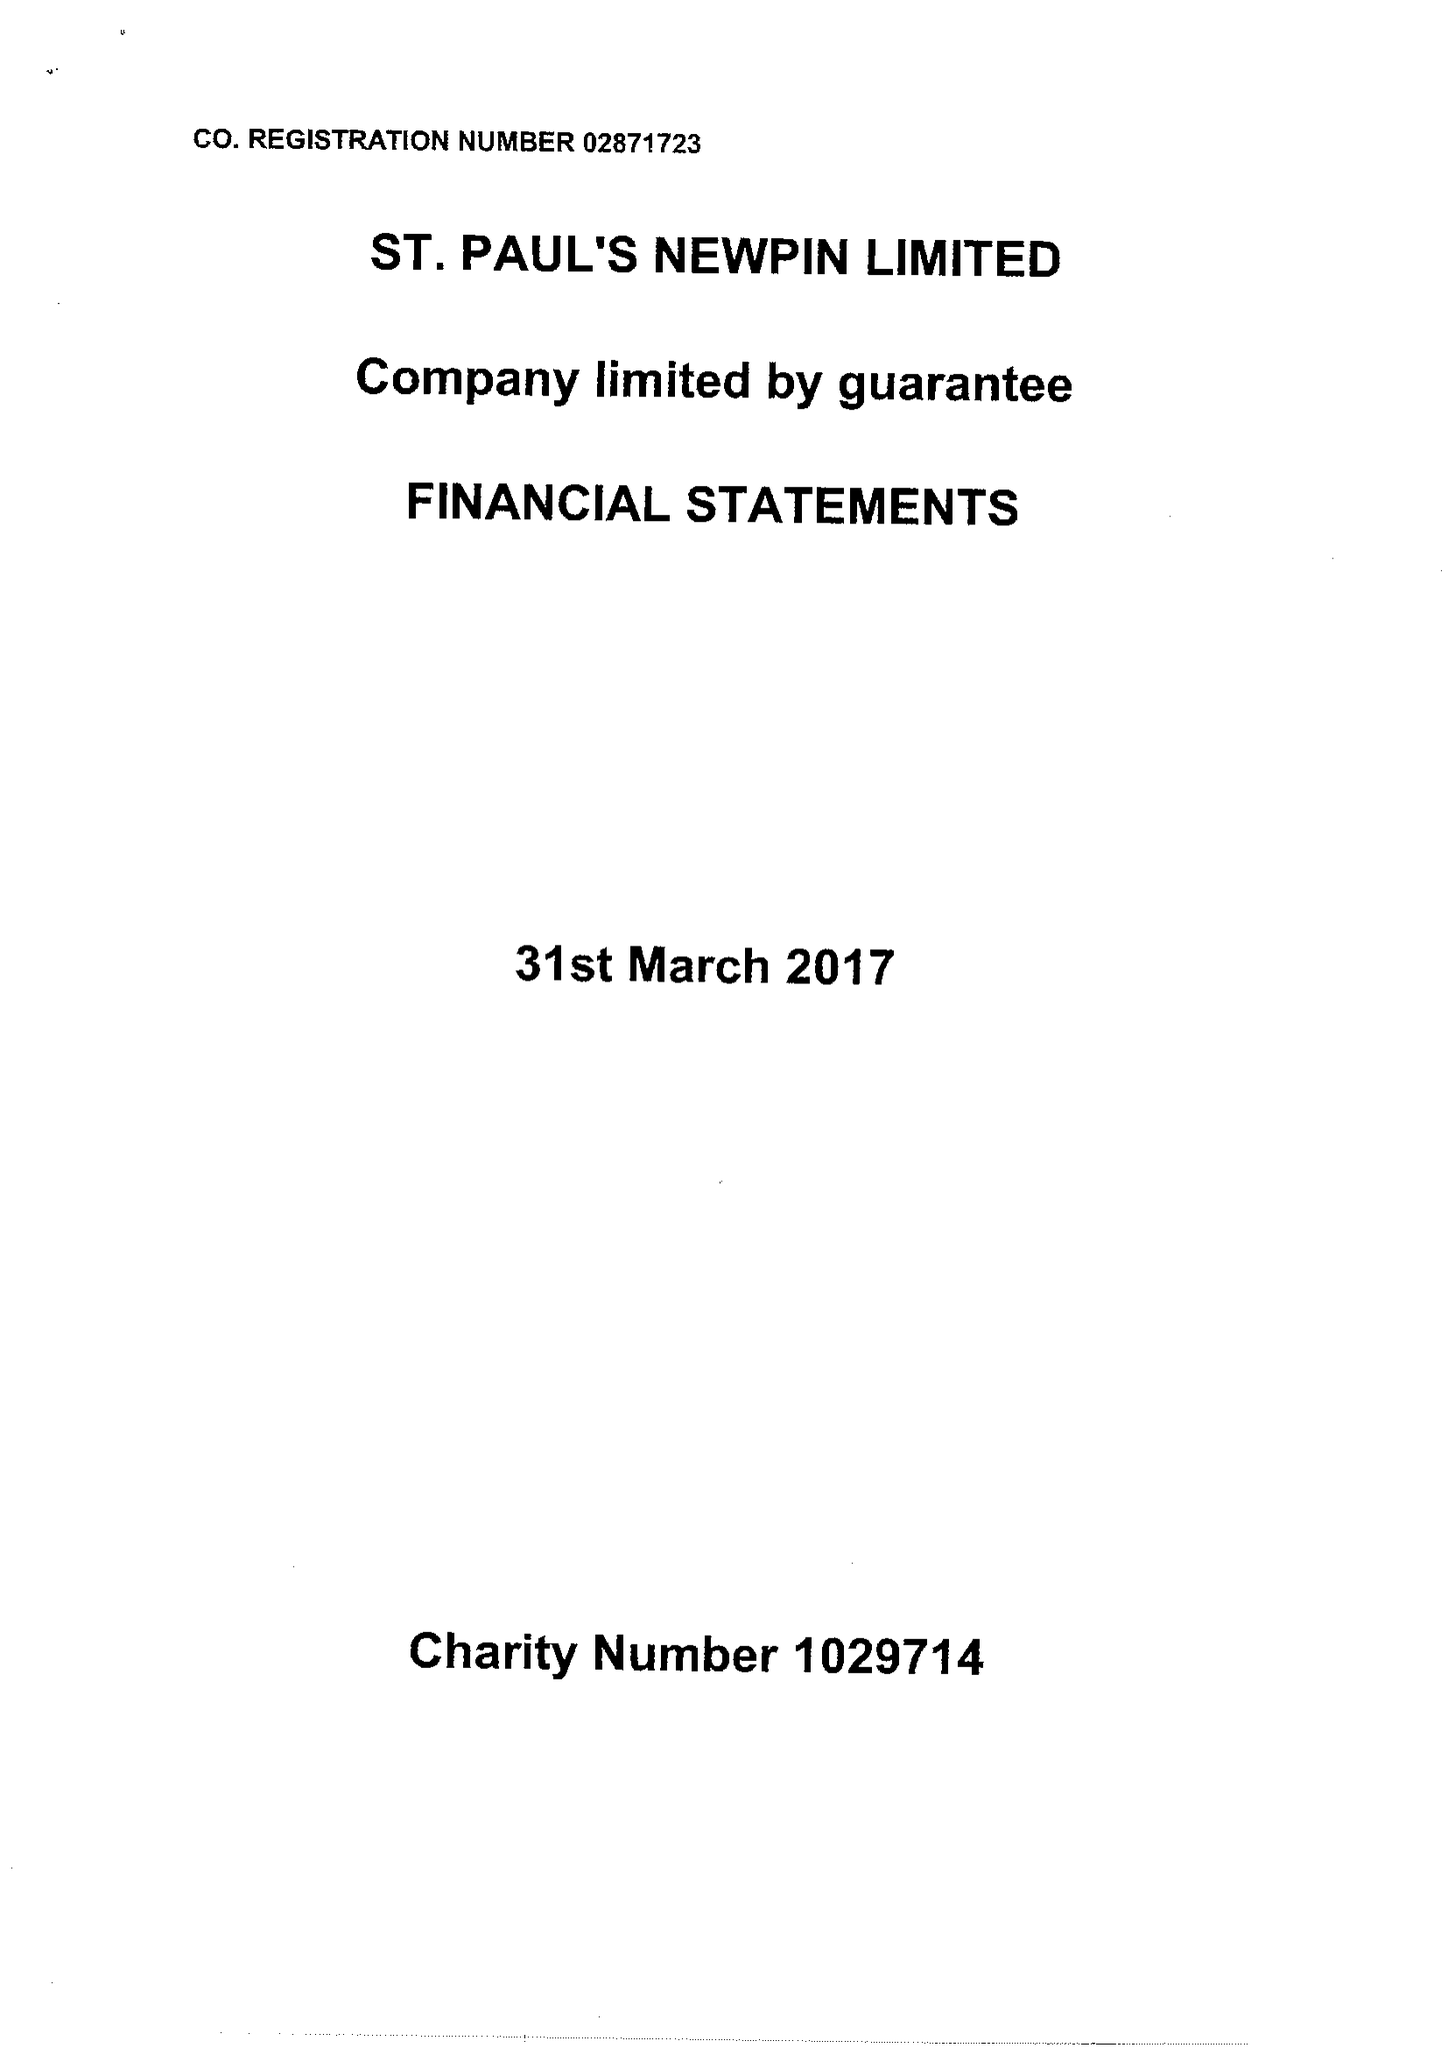What is the value for the report_date?
Answer the question using a single word or phrase. 2017-03-31 